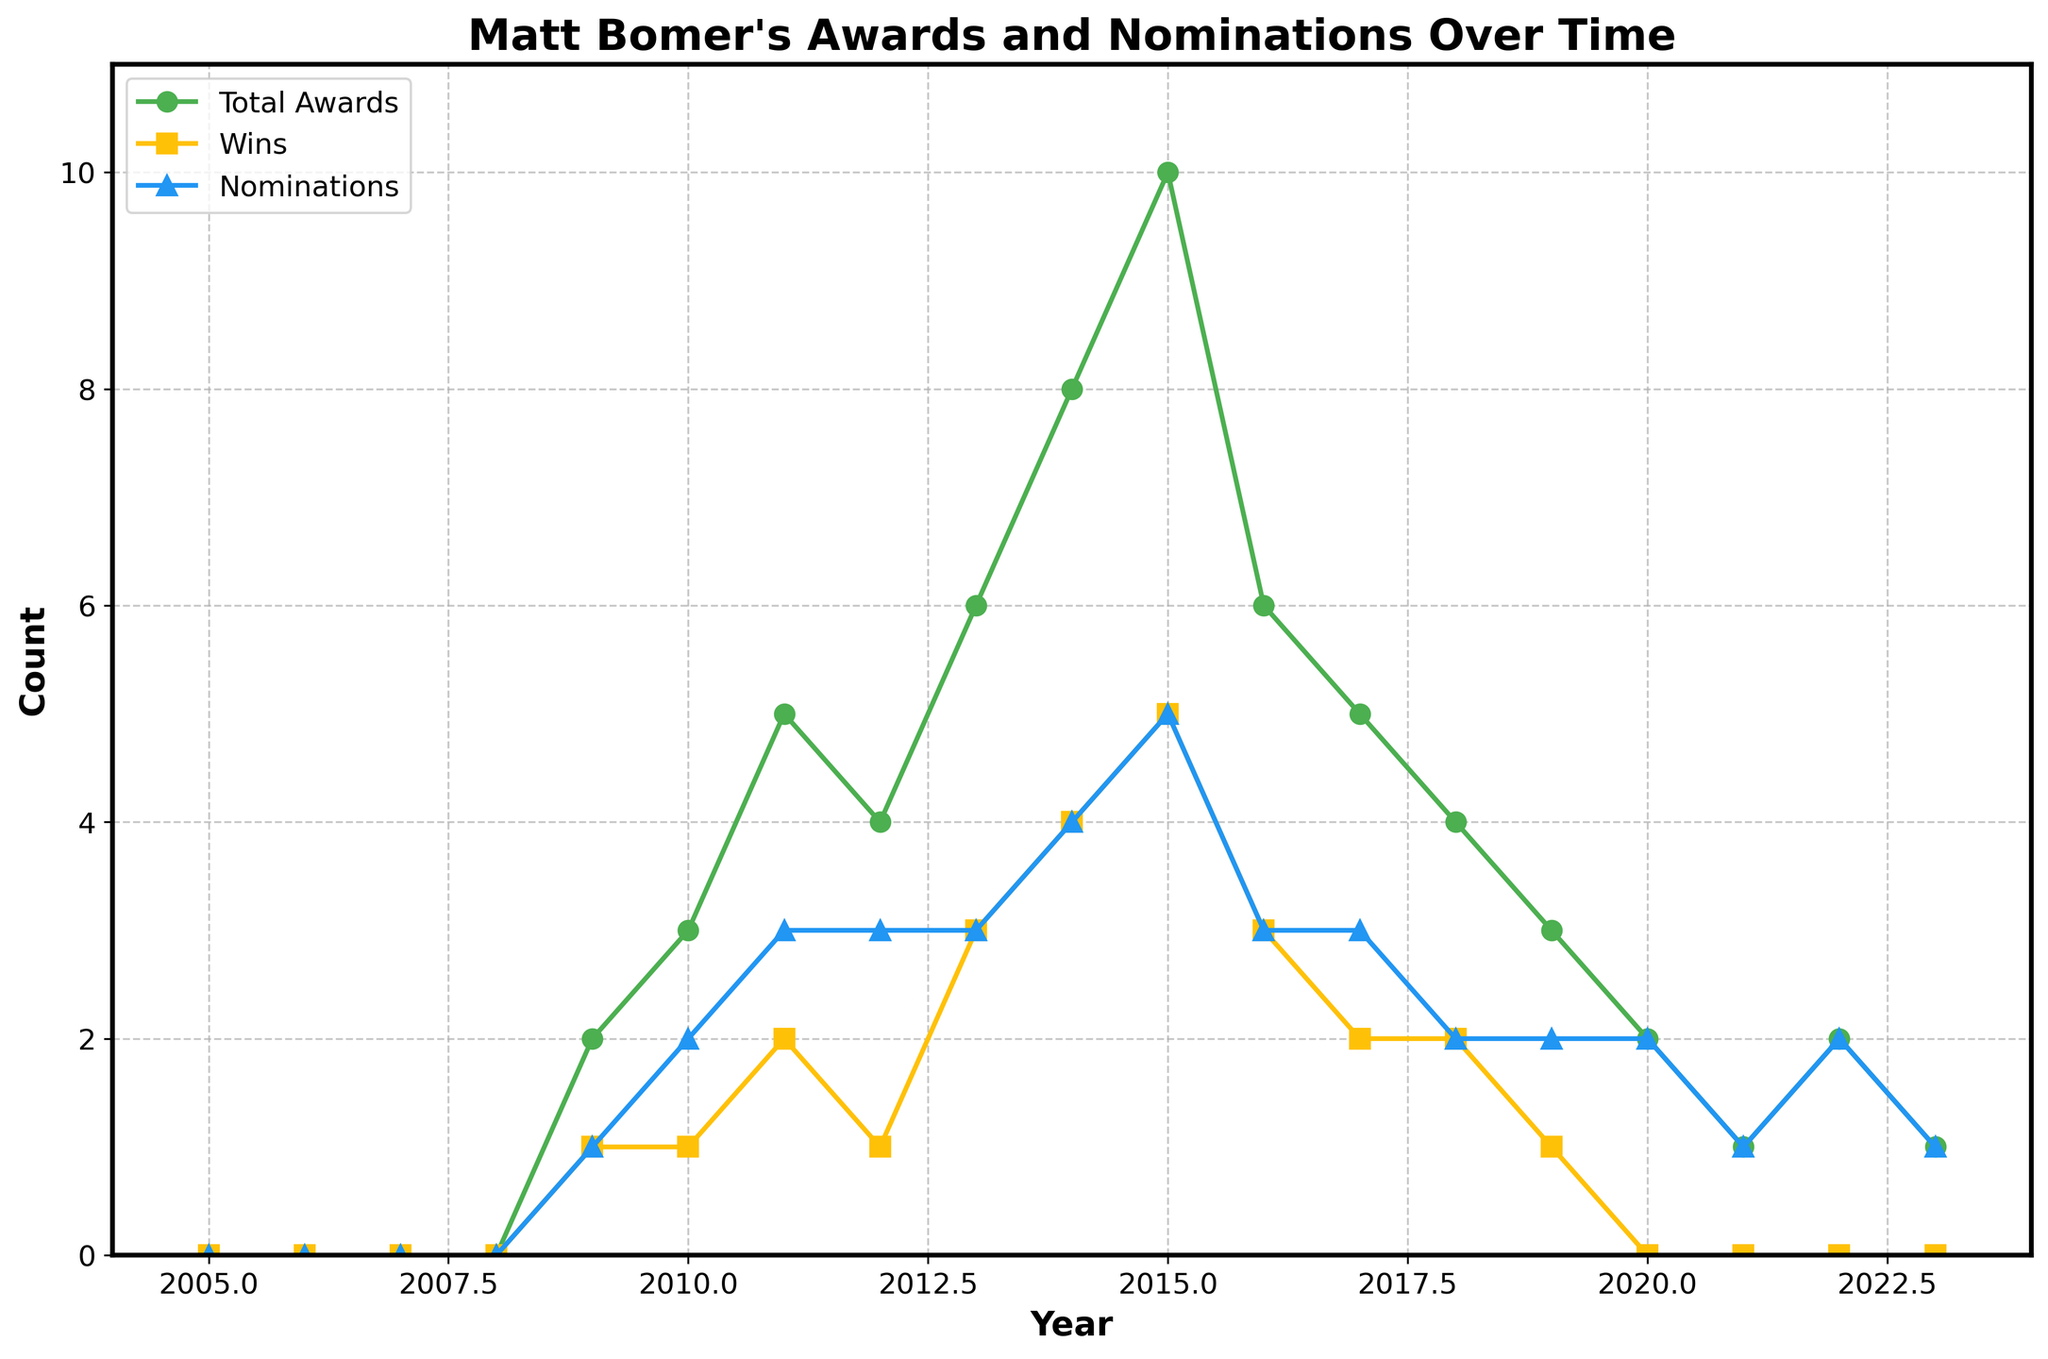What's the title of the plot? The title of the plot is located at the top of the figure. It describes what the plot is about.
Answer: "Matt Bomer's Awards and Nominations Over Time" How many awards did Matt Bomer win in 2015? Look at the data point for the year 2015 on the plot representing wins.
Answer: 5 In which year did Matt Bomer receive the most nominations? Find the highest peak in the nominations series (blue line) and note the corresponding year.
Answer: 2014 What was the total number of awards, wins, and nominations in 2010? Refer to the points for the year 2010 in all three series.
Answer: Awards: 3, Wins: 1, Nominations: 2 How do the number of wins in 2013 compare to 2023? Find the data points for wins in 2013 and 2023 and compare their values.
Answer: More wins in 2013 (3) than in 2023 (0) What is the difference between the total number of awards in 2014 and 2016? Subtract the number of awards in 2016 from the number of awards in 2014.
Answer: 2 (8 awards in 2014 - 6 awards in 2016) What trend can be observed in Matt Bomer's nominations from 2018 to 2023? Observe the pattern formed by the nominations series (blue line) from 2018 to 2023.
Answer: Generally decreasing What is the average number of wins per year from 2009 to 2015? Add up the wins from 2009 to 2015, then divide by the number of years (7).
Answer: (1+1+2+1+3+4+5) / 7 = 2 Between which years did Matt Bomer experience the largest increase in total awards? Observe the largest jump in the total awards series (green line) between consecutive years.
Answer: 2013 to 2014 What is the general trend observed in Matt Bomer's total awards from 2005 to 2023? Analyze the overall direction of the total awards series (green line) from start to end of the period.
Answer: Increasing until 2015, then fluctuating 